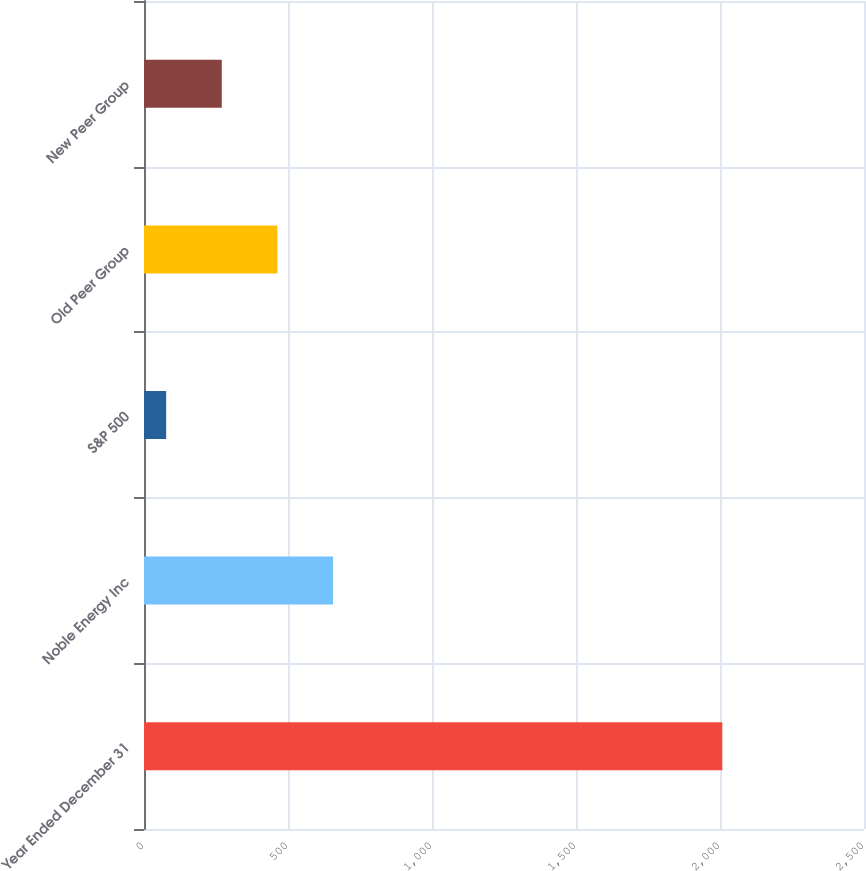<chart> <loc_0><loc_0><loc_500><loc_500><bar_chart><fcel>Year Ended December 31<fcel>Noble Energy Inc<fcel>S&P 500<fcel>Old Peer Group<fcel>New Peer Group<nl><fcel>2008<fcel>656.26<fcel>76.96<fcel>463.16<fcel>270.06<nl></chart> 